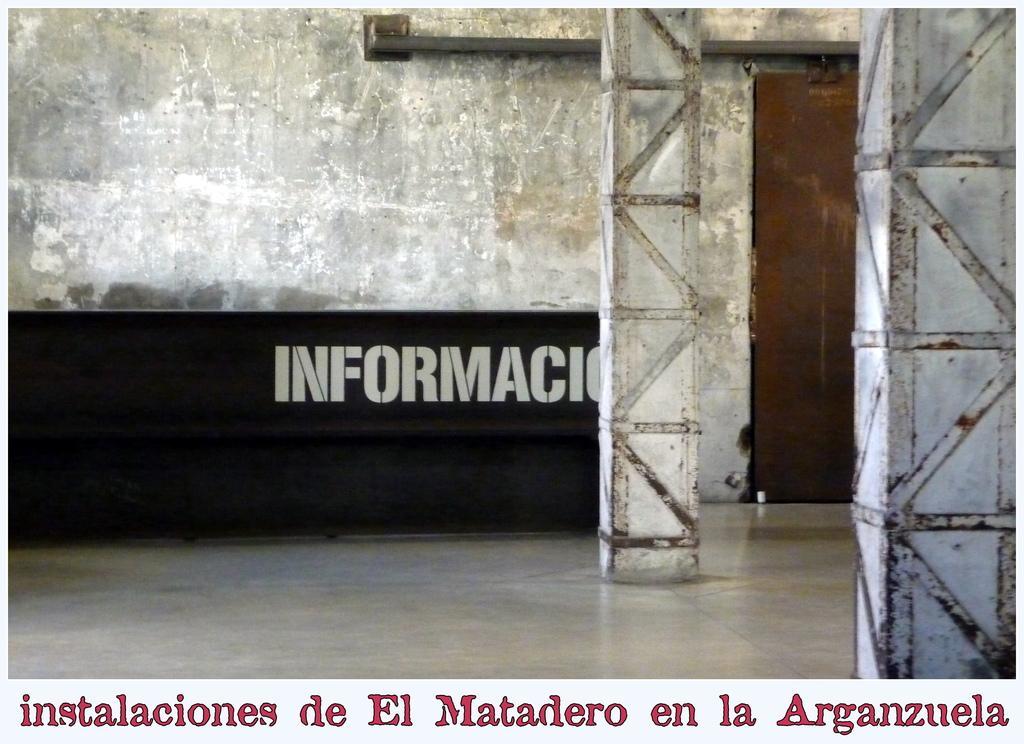Please provide a concise description of this image. In this image we can see a wall with some text on it, some pillars and a door. On the bottom of the image we can see some text. 